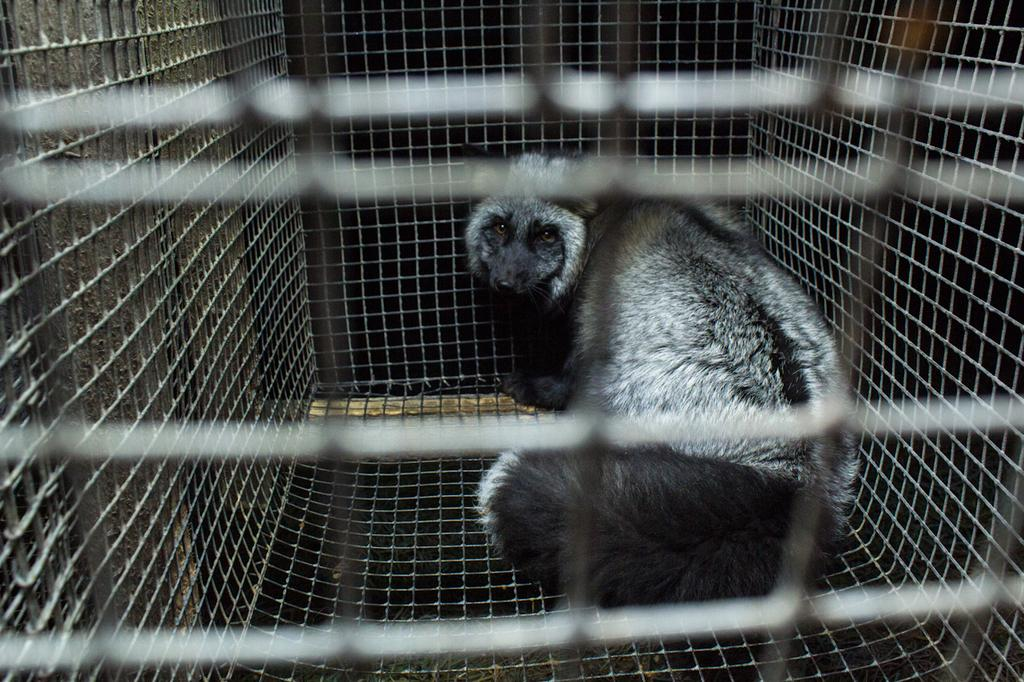What type of creature can be seen in the image? There is an animal in the image. Where is the animal located? The animal is in a cage. What theory is being proposed by the animal in the image? There is no indication in the image that the animal is proposing a theory. 